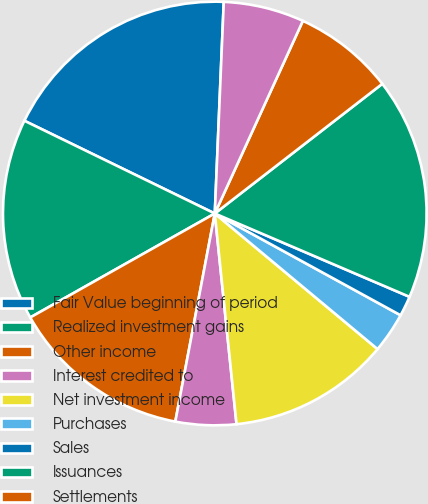Convert chart to OTSL. <chart><loc_0><loc_0><loc_500><loc_500><pie_chart><fcel>Fair Value beginning of period<fcel>Realized investment gains<fcel>Other income<fcel>Interest credited to<fcel>Net investment income<fcel>Purchases<fcel>Sales<fcel>Issuances<fcel>Settlements<fcel>Foreign currency translation<nl><fcel>18.46%<fcel>15.38%<fcel>13.85%<fcel>4.62%<fcel>12.31%<fcel>3.08%<fcel>1.54%<fcel>16.92%<fcel>7.69%<fcel>6.15%<nl></chart> 